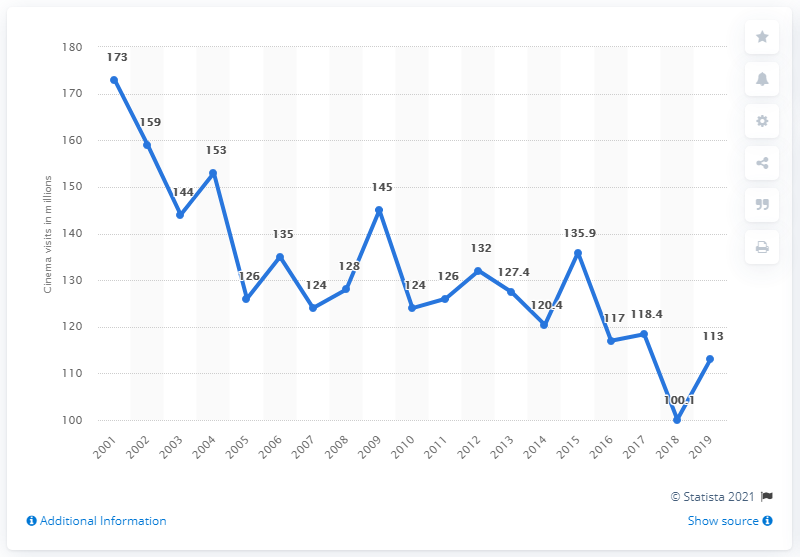Point out several critical features in this image. In 2019, the number of people who visited German cinemas was 113... 